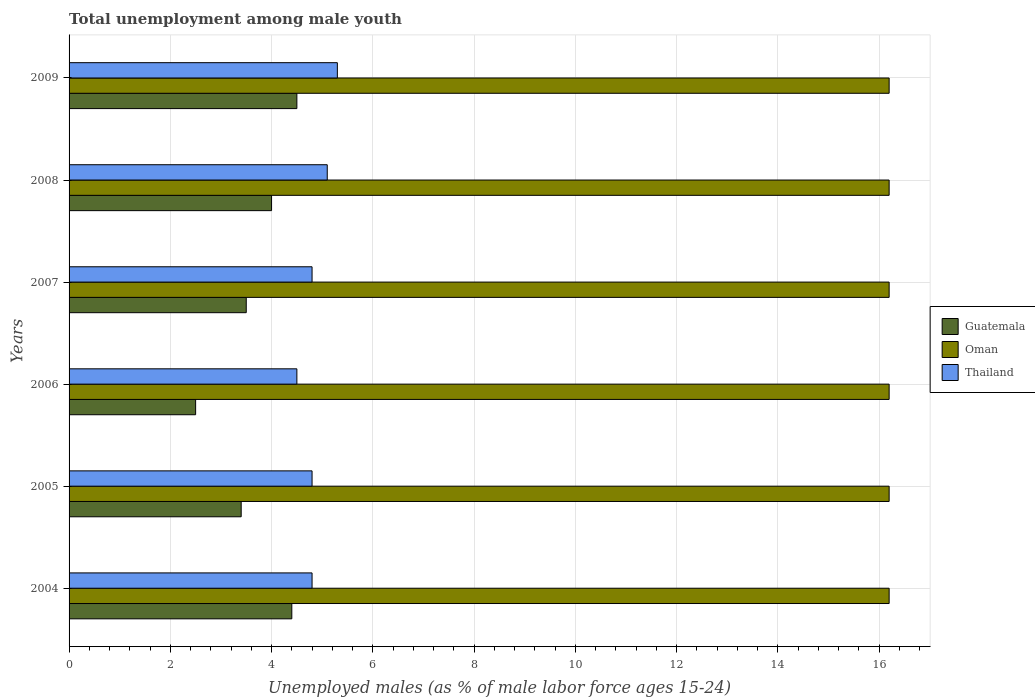How many different coloured bars are there?
Make the answer very short. 3. Are the number of bars per tick equal to the number of legend labels?
Offer a very short reply. Yes. How many bars are there on the 5th tick from the bottom?
Your answer should be compact. 3. What is the percentage of unemployed males in in Oman in 2009?
Give a very brief answer. 16.2. Across all years, what is the maximum percentage of unemployed males in in Thailand?
Give a very brief answer. 5.3. What is the total percentage of unemployed males in in Guatemala in the graph?
Your answer should be compact. 22.3. What is the difference between the percentage of unemployed males in in Guatemala in 2005 and that in 2006?
Provide a succinct answer. 0.9. What is the difference between the percentage of unemployed males in in Guatemala in 2006 and the percentage of unemployed males in in Thailand in 2007?
Keep it short and to the point. -2.3. What is the average percentage of unemployed males in in Guatemala per year?
Provide a short and direct response. 3.72. In the year 2009, what is the difference between the percentage of unemployed males in in Oman and percentage of unemployed males in in Guatemala?
Give a very brief answer. 11.7. What is the ratio of the percentage of unemployed males in in Guatemala in 2004 to that in 2006?
Provide a short and direct response. 1.76. Is the percentage of unemployed males in in Thailand in 2007 less than that in 2008?
Provide a succinct answer. Yes. What is the difference between the highest and the lowest percentage of unemployed males in in Thailand?
Your answer should be compact. 0.8. In how many years, is the percentage of unemployed males in in Oman greater than the average percentage of unemployed males in in Oman taken over all years?
Offer a very short reply. 0. What does the 1st bar from the top in 2007 represents?
Ensure brevity in your answer.  Thailand. What does the 2nd bar from the bottom in 2009 represents?
Keep it short and to the point. Oman. Is it the case that in every year, the sum of the percentage of unemployed males in in Guatemala and percentage of unemployed males in in Thailand is greater than the percentage of unemployed males in in Oman?
Keep it short and to the point. No. Are all the bars in the graph horizontal?
Give a very brief answer. Yes. How many years are there in the graph?
Keep it short and to the point. 6. Are the values on the major ticks of X-axis written in scientific E-notation?
Your answer should be compact. No. Does the graph contain any zero values?
Ensure brevity in your answer.  No. Does the graph contain grids?
Ensure brevity in your answer.  Yes. Where does the legend appear in the graph?
Offer a terse response. Center right. How are the legend labels stacked?
Offer a terse response. Vertical. What is the title of the graph?
Your response must be concise. Total unemployment among male youth. Does "Colombia" appear as one of the legend labels in the graph?
Provide a succinct answer. No. What is the label or title of the X-axis?
Make the answer very short. Unemployed males (as % of male labor force ages 15-24). What is the Unemployed males (as % of male labor force ages 15-24) in Guatemala in 2004?
Offer a terse response. 4.4. What is the Unemployed males (as % of male labor force ages 15-24) of Oman in 2004?
Ensure brevity in your answer.  16.2. What is the Unemployed males (as % of male labor force ages 15-24) of Thailand in 2004?
Give a very brief answer. 4.8. What is the Unemployed males (as % of male labor force ages 15-24) in Guatemala in 2005?
Provide a short and direct response. 3.4. What is the Unemployed males (as % of male labor force ages 15-24) of Oman in 2005?
Offer a terse response. 16.2. What is the Unemployed males (as % of male labor force ages 15-24) in Thailand in 2005?
Ensure brevity in your answer.  4.8. What is the Unemployed males (as % of male labor force ages 15-24) in Oman in 2006?
Keep it short and to the point. 16.2. What is the Unemployed males (as % of male labor force ages 15-24) in Guatemala in 2007?
Offer a very short reply. 3.5. What is the Unemployed males (as % of male labor force ages 15-24) in Oman in 2007?
Make the answer very short. 16.2. What is the Unemployed males (as % of male labor force ages 15-24) of Thailand in 2007?
Your answer should be very brief. 4.8. What is the Unemployed males (as % of male labor force ages 15-24) of Guatemala in 2008?
Your answer should be compact. 4. What is the Unemployed males (as % of male labor force ages 15-24) of Oman in 2008?
Keep it short and to the point. 16.2. What is the Unemployed males (as % of male labor force ages 15-24) of Thailand in 2008?
Ensure brevity in your answer.  5.1. What is the Unemployed males (as % of male labor force ages 15-24) in Guatemala in 2009?
Your response must be concise. 4.5. What is the Unemployed males (as % of male labor force ages 15-24) in Oman in 2009?
Provide a short and direct response. 16.2. What is the Unemployed males (as % of male labor force ages 15-24) of Thailand in 2009?
Your answer should be very brief. 5.3. Across all years, what is the maximum Unemployed males (as % of male labor force ages 15-24) of Guatemala?
Provide a short and direct response. 4.5. Across all years, what is the maximum Unemployed males (as % of male labor force ages 15-24) of Oman?
Your response must be concise. 16.2. Across all years, what is the maximum Unemployed males (as % of male labor force ages 15-24) of Thailand?
Ensure brevity in your answer.  5.3. Across all years, what is the minimum Unemployed males (as % of male labor force ages 15-24) of Oman?
Provide a succinct answer. 16.2. Across all years, what is the minimum Unemployed males (as % of male labor force ages 15-24) of Thailand?
Your response must be concise. 4.5. What is the total Unemployed males (as % of male labor force ages 15-24) in Guatemala in the graph?
Offer a terse response. 22.3. What is the total Unemployed males (as % of male labor force ages 15-24) in Oman in the graph?
Your answer should be very brief. 97.2. What is the total Unemployed males (as % of male labor force ages 15-24) of Thailand in the graph?
Offer a terse response. 29.3. What is the difference between the Unemployed males (as % of male labor force ages 15-24) of Thailand in 2004 and that in 2005?
Provide a succinct answer. 0. What is the difference between the Unemployed males (as % of male labor force ages 15-24) of Guatemala in 2004 and that in 2006?
Provide a short and direct response. 1.9. What is the difference between the Unemployed males (as % of male labor force ages 15-24) in Oman in 2004 and that in 2006?
Provide a short and direct response. 0. What is the difference between the Unemployed males (as % of male labor force ages 15-24) in Guatemala in 2004 and that in 2007?
Keep it short and to the point. 0.9. What is the difference between the Unemployed males (as % of male labor force ages 15-24) in Thailand in 2004 and that in 2007?
Offer a terse response. 0. What is the difference between the Unemployed males (as % of male labor force ages 15-24) in Guatemala in 2004 and that in 2008?
Your response must be concise. 0.4. What is the difference between the Unemployed males (as % of male labor force ages 15-24) of Oman in 2004 and that in 2008?
Provide a short and direct response. 0. What is the difference between the Unemployed males (as % of male labor force ages 15-24) in Thailand in 2004 and that in 2009?
Your response must be concise. -0.5. What is the difference between the Unemployed males (as % of male labor force ages 15-24) in Oman in 2005 and that in 2006?
Ensure brevity in your answer.  0. What is the difference between the Unemployed males (as % of male labor force ages 15-24) of Thailand in 2005 and that in 2006?
Your response must be concise. 0.3. What is the difference between the Unemployed males (as % of male labor force ages 15-24) of Guatemala in 2005 and that in 2009?
Offer a very short reply. -1.1. What is the difference between the Unemployed males (as % of male labor force ages 15-24) in Oman in 2006 and that in 2007?
Provide a short and direct response. 0. What is the difference between the Unemployed males (as % of male labor force ages 15-24) in Guatemala in 2006 and that in 2008?
Offer a terse response. -1.5. What is the difference between the Unemployed males (as % of male labor force ages 15-24) in Thailand in 2006 and that in 2008?
Offer a very short reply. -0.6. What is the difference between the Unemployed males (as % of male labor force ages 15-24) of Guatemala in 2006 and that in 2009?
Offer a very short reply. -2. What is the difference between the Unemployed males (as % of male labor force ages 15-24) in Oman in 2007 and that in 2008?
Your answer should be compact. 0. What is the difference between the Unemployed males (as % of male labor force ages 15-24) in Thailand in 2007 and that in 2008?
Give a very brief answer. -0.3. What is the difference between the Unemployed males (as % of male labor force ages 15-24) of Guatemala in 2007 and that in 2009?
Your answer should be very brief. -1. What is the difference between the Unemployed males (as % of male labor force ages 15-24) of Oman in 2007 and that in 2009?
Ensure brevity in your answer.  0. What is the difference between the Unemployed males (as % of male labor force ages 15-24) in Thailand in 2007 and that in 2009?
Provide a succinct answer. -0.5. What is the difference between the Unemployed males (as % of male labor force ages 15-24) in Guatemala in 2004 and the Unemployed males (as % of male labor force ages 15-24) in Oman in 2005?
Your answer should be compact. -11.8. What is the difference between the Unemployed males (as % of male labor force ages 15-24) in Oman in 2004 and the Unemployed males (as % of male labor force ages 15-24) in Thailand in 2005?
Your answer should be very brief. 11.4. What is the difference between the Unemployed males (as % of male labor force ages 15-24) of Guatemala in 2004 and the Unemployed males (as % of male labor force ages 15-24) of Oman in 2007?
Your answer should be very brief. -11.8. What is the difference between the Unemployed males (as % of male labor force ages 15-24) in Guatemala in 2004 and the Unemployed males (as % of male labor force ages 15-24) in Thailand in 2007?
Offer a terse response. -0.4. What is the difference between the Unemployed males (as % of male labor force ages 15-24) in Oman in 2004 and the Unemployed males (as % of male labor force ages 15-24) in Thailand in 2007?
Provide a succinct answer. 11.4. What is the difference between the Unemployed males (as % of male labor force ages 15-24) in Guatemala in 2004 and the Unemployed males (as % of male labor force ages 15-24) in Oman in 2008?
Ensure brevity in your answer.  -11.8. What is the difference between the Unemployed males (as % of male labor force ages 15-24) in Guatemala in 2004 and the Unemployed males (as % of male labor force ages 15-24) in Thailand in 2008?
Make the answer very short. -0.7. What is the difference between the Unemployed males (as % of male labor force ages 15-24) in Guatemala in 2004 and the Unemployed males (as % of male labor force ages 15-24) in Oman in 2009?
Offer a terse response. -11.8. What is the difference between the Unemployed males (as % of male labor force ages 15-24) in Guatemala in 2004 and the Unemployed males (as % of male labor force ages 15-24) in Thailand in 2009?
Make the answer very short. -0.9. What is the difference between the Unemployed males (as % of male labor force ages 15-24) of Guatemala in 2005 and the Unemployed males (as % of male labor force ages 15-24) of Oman in 2006?
Your response must be concise. -12.8. What is the difference between the Unemployed males (as % of male labor force ages 15-24) of Oman in 2005 and the Unemployed males (as % of male labor force ages 15-24) of Thailand in 2006?
Your response must be concise. 11.7. What is the difference between the Unemployed males (as % of male labor force ages 15-24) of Guatemala in 2005 and the Unemployed males (as % of male labor force ages 15-24) of Thailand in 2007?
Give a very brief answer. -1.4. What is the difference between the Unemployed males (as % of male labor force ages 15-24) in Oman in 2005 and the Unemployed males (as % of male labor force ages 15-24) in Thailand in 2007?
Provide a short and direct response. 11.4. What is the difference between the Unemployed males (as % of male labor force ages 15-24) in Guatemala in 2005 and the Unemployed males (as % of male labor force ages 15-24) in Thailand in 2008?
Keep it short and to the point. -1.7. What is the difference between the Unemployed males (as % of male labor force ages 15-24) of Guatemala in 2006 and the Unemployed males (as % of male labor force ages 15-24) of Oman in 2007?
Offer a terse response. -13.7. What is the difference between the Unemployed males (as % of male labor force ages 15-24) in Guatemala in 2006 and the Unemployed males (as % of male labor force ages 15-24) in Oman in 2008?
Your answer should be compact. -13.7. What is the difference between the Unemployed males (as % of male labor force ages 15-24) in Guatemala in 2006 and the Unemployed males (as % of male labor force ages 15-24) in Thailand in 2008?
Make the answer very short. -2.6. What is the difference between the Unemployed males (as % of male labor force ages 15-24) in Oman in 2006 and the Unemployed males (as % of male labor force ages 15-24) in Thailand in 2008?
Make the answer very short. 11.1. What is the difference between the Unemployed males (as % of male labor force ages 15-24) of Guatemala in 2006 and the Unemployed males (as % of male labor force ages 15-24) of Oman in 2009?
Your answer should be compact. -13.7. What is the difference between the Unemployed males (as % of male labor force ages 15-24) of Guatemala in 2007 and the Unemployed males (as % of male labor force ages 15-24) of Thailand in 2008?
Your answer should be very brief. -1.6. What is the difference between the Unemployed males (as % of male labor force ages 15-24) of Oman in 2007 and the Unemployed males (as % of male labor force ages 15-24) of Thailand in 2008?
Offer a terse response. 11.1. What is the difference between the Unemployed males (as % of male labor force ages 15-24) in Oman in 2007 and the Unemployed males (as % of male labor force ages 15-24) in Thailand in 2009?
Ensure brevity in your answer.  10.9. What is the difference between the Unemployed males (as % of male labor force ages 15-24) in Oman in 2008 and the Unemployed males (as % of male labor force ages 15-24) in Thailand in 2009?
Your answer should be very brief. 10.9. What is the average Unemployed males (as % of male labor force ages 15-24) of Guatemala per year?
Make the answer very short. 3.72. What is the average Unemployed males (as % of male labor force ages 15-24) in Oman per year?
Your answer should be very brief. 16.2. What is the average Unemployed males (as % of male labor force ages 15-24) in Thailand per year?
Make the answer very short. 4.88. In the year 2004, what is the difference between the Unemployed males (as % of male labor force ages 15-24) in Guatemala and Unemployed males (as % of male labor force ages 15-24) in Thailand?
Provide a succinct answer. -0.4. In the year 2006, what is the difference between the Unemployed males (as % of male labor force ages 15-24) of Guatemala and Unemployed males (as % of male labor force ages 15-24) of Oman?
Provide a succinct answer. -13.7. In the year 2006, what is the difference between the Unemployed males (as % of male labor force ages 15-24) of Guatemala and Unemployed males (as % of male labor force ages 15-24) of Thailand?
Ensure brevity in your answer.  -2. In the year 2007, what is the difference between the Unemployed males (as % of male labor force ages 15-24) of Guatemala and Unemployed males (as % of male labor force ages 15-24) of Oman?
Your answer should be compact. -12.7. In the year 2007, what is the difference between the Unemployed males (as % of male labor force ages 15-24) in Oman and Unemployed males (as % of male labor force ages 15-24) in Thailand?
Make the answer very short. 11.4. In the year 2008, what is the difference between the Unemployed males (as % of male labor force ages 15-24) of Guatemala and Unemployed males (as % of male labor force ages 15-24) of Oman?
Your response must be concise. -12.2. In the year 2009, what is the difference between the Unemployed males (as % of male labor force ages 15-24) in Guatemala and Unemployed males (as % of male labor force ages 15-24) in Oman?
Keep it short and to the point. -11.7. In the year 2009, what is the difference between the Unemployed males (as % of male labor force ages 15-24) in Guatemala and Unemployed males (as % of male labor force ages 15-24) in Thailand?
Provide a short and direct response. -0.8. What is the ratio of the Unemployed males (as % of male labor force ages 15-24) in Guatemala in 2004 to that in 2005?
Your answer should be compact. 1.29. What is the ratio of the Unemployed males (as % of male labor force ages 15-24) of Oman in 2004 to that in 2005?
Provide a succinct answer. 1. What is the ratio of the Unemployed males (as % of male labor force ages 15-24) of Guatemala in 2004 to that in 2006?
Your response must be concise. 1.76. What is the ratio of the Unemployed males (as % of male labor force ages 15-24) in Thailand in 2004 to that in 2006?
Provide a short and direct response. 1.07. What is the ratio of the Unemployed males (as % of male labor force ages 15-24) in Guatemala in 2004 to that in 2007?
Keep it short and to the point. 1.26. What is the ratio of the Unemployed males (as % of male labor force ages 15-24) in Oman in 2004 to that in 2008?
Your answer should be compact. 1. What is the ratio of the Unemployed males (as % of male labor force ages 15-24) of Thailand in 2004 to that in 2008?
Provide a short and direct response. 0.94. What is the ratio of the Unemployed males (as % of male labor force ages 15-24) in Guatemala in 2004 to that in 2009?
Offer a terse response. 0.98. What is the ratio of the Unemployed males (as % of male labor force ages 15-24) in Oman in 2004 to that in 2009?
Keep it short and to the point. 1. What is the ratio of the Unemployed males (as % of male labor force ages 15-24) in Thailand in 2004 to that in 2009?
Your answer should be compact. 0.91. What is the ratio of the Unemployed males (as % of male labor force ages 15-24) of Guatemala in 2005 to that in 2006?
Your answer should be compact. 1.36. What is the ratio of the Unemployed males (as % of male labor force ages 15-24) in Thailand in 2005 to that in 2006?
Ensure brevity in your answer.  1.07. What is the ratio of the Unemployed males (as % of male labor force ages 15-24) in Guatemala in 2005 to that in 2007?
Offer a terse response. 0.97. What is the ratio of the Unemployed males (as % of male labor force ages 15-24) of Thailand in 2005 to that in 2007?
Give a very brief answer. 1. What is the ratio of the Unemployed males (as % of male labor force ages 15-24) of Guatemala in 2005 to that in 2008?
Keep it short and to the point. 0.85. What is the ratio of the Unemployed males (as % of male labor force ages 15-24) in Oman in 2005 to that in 2008?
Your response must be concise. 1. What is the ratio of the Unemployed males (as % of male labor force ages 15-24) of Guatemala in 2005 to that in 2009?
Keep it short and to the point. 0.76. What is the ratio of the Unemployed males (as % of male labor force ages 15-24) of Thailand in 2005 to that in 2009?
Your answer should be compact. 0.91. What is the ratio of the Unemployed males (as % of male labor force ages 15-24) in Guatemala in 2006 to that in 2007?
Offer a very short reply. 0.71. What is the ratio of the Unemployed males (as % of male labor force ages 15-24) of Oman in 2006 to that in 2007?
Provide a short and direct response. 1. What is the ratio of the Unemployed males (as % of male labor force ages 15-24) of Thailand in 2006 to that in 2007?
Make the answer very short. 0.94. What is the ratio of the Unemployed males (as % of male labor force ages 15-24) of Thailand in 2006 to that in 2008?
Your answer should be very brief. 0.88. What is the ratio of the Unemployed males (as % of male labor force ages 15-24) in Guatemala in 2006 to that in 2009?
Keep it short and to the point. 0.56. What is the ratio of the Unemployed males (as % of male labor force ages 15-24) in Thailand in 2006 to that in 2009?
Offer a very short reply. 0.85. What is the ratio of the Unemployed males (as % of male labor force ages 15-24) in Thailand in 2007 to that in 2008?
Provide a succinct answer. 0.94. What is the ratio of the Unemployed males (as % of male labor force ages 15-24) in Guatemala in 2007 to that in 2009?
Provide a short and direct response. 0.78. What is the ratio of the Unemployed males (as % of male labor force ages 15-24) in Oman in 2007 to that in 2009?
Offer a very short reply. 1. What is the ratio of the Unemployed males (as % of male labor force ages 15-24) in Thailand in 2007 to that in 2009?
Keep it short and to the point. 0.91. What is the ratio of the Unemployed males (as % of male labor force ages 15-24) of Guatemala in 2008 to that in 2009?
Make the answer very short. 0.89. What is the ratio of the Unemployed males (as % of male labor force ages 15-24) of Thailand in 2008 to that in 2009?
Give a very brief answer. 0.96. What is the difference between the highest and the second highest Unemployed males (as % of male labor force ages 15-24) in Guatemala?
Provide a succinct answer. 0.1. What is the difference between the highest and the lowest Unemployed males (as % of male labor force ages 15-24) in Guatemala?
Offer a terse response. 2. 